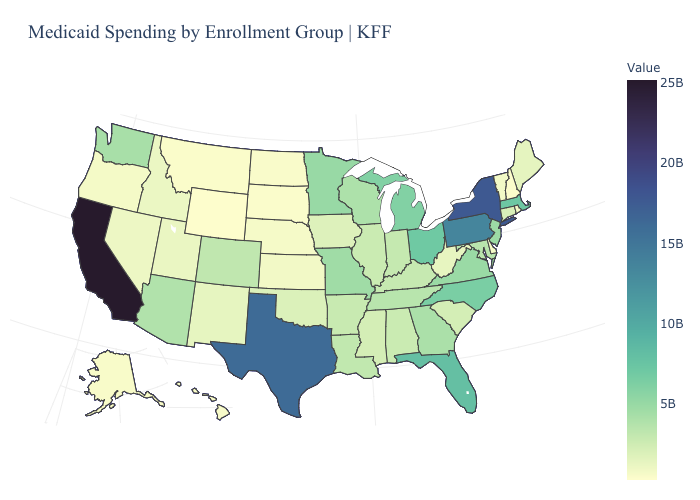Does Wyoming have the lowest value in the West?
Concise answer only. Yes. Does California have the highest value in the USA?
Write a very short answer. Yes. Which states have the lowest value in the USA?
Write a very short answer. Wyoming. Among the states that border California , does Arizona have the highest value?
Short answer required. Yes. 